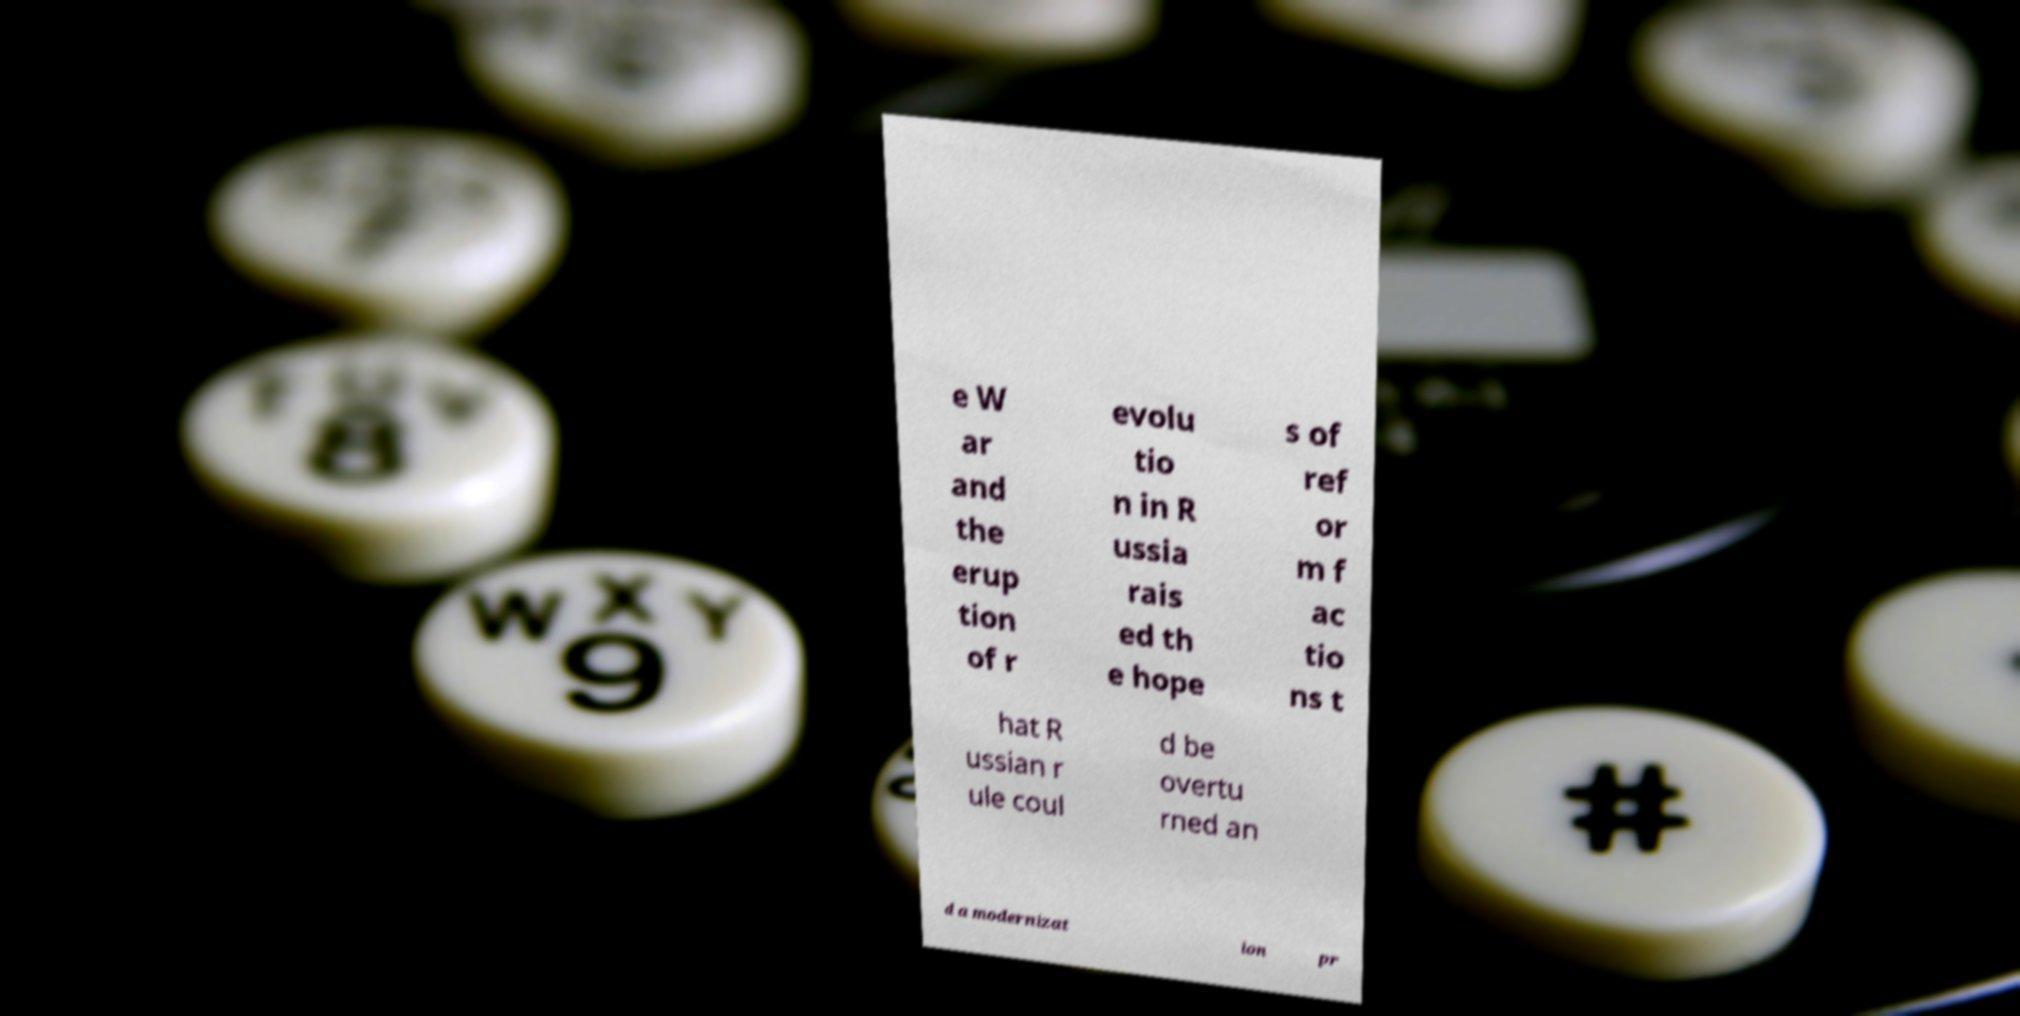Please read and relay the text visible in this image. What does it say? e W ar and the erup tion of r evolu tio n in R ussia rais ed th e hope s of ref or m f ac tio ns t hat R ussian r ule coul d be overtu rned an d a modernizat ion pr 